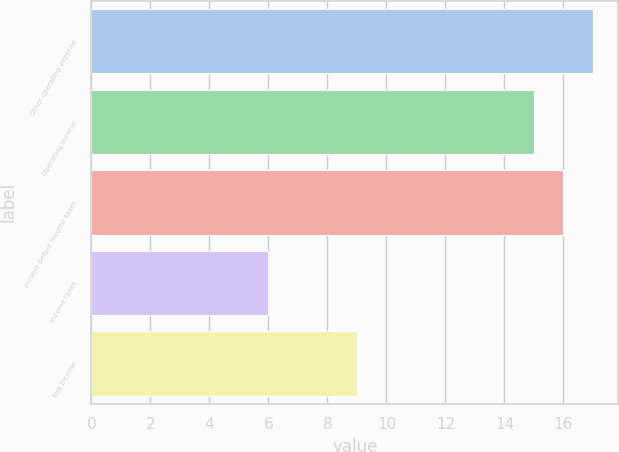Convert chart. <chart><loc_0><loc_0><loc_500><loc_500><bar_chart><fcel>Other operating expense<fcel>Operating Income<fcel>Income before income taxes<fcel>Income taxes<fcel>Net Income<nl><fcel>17<fcel>15<fcel>16<fcel>6<fcel>9<nl></chart> 